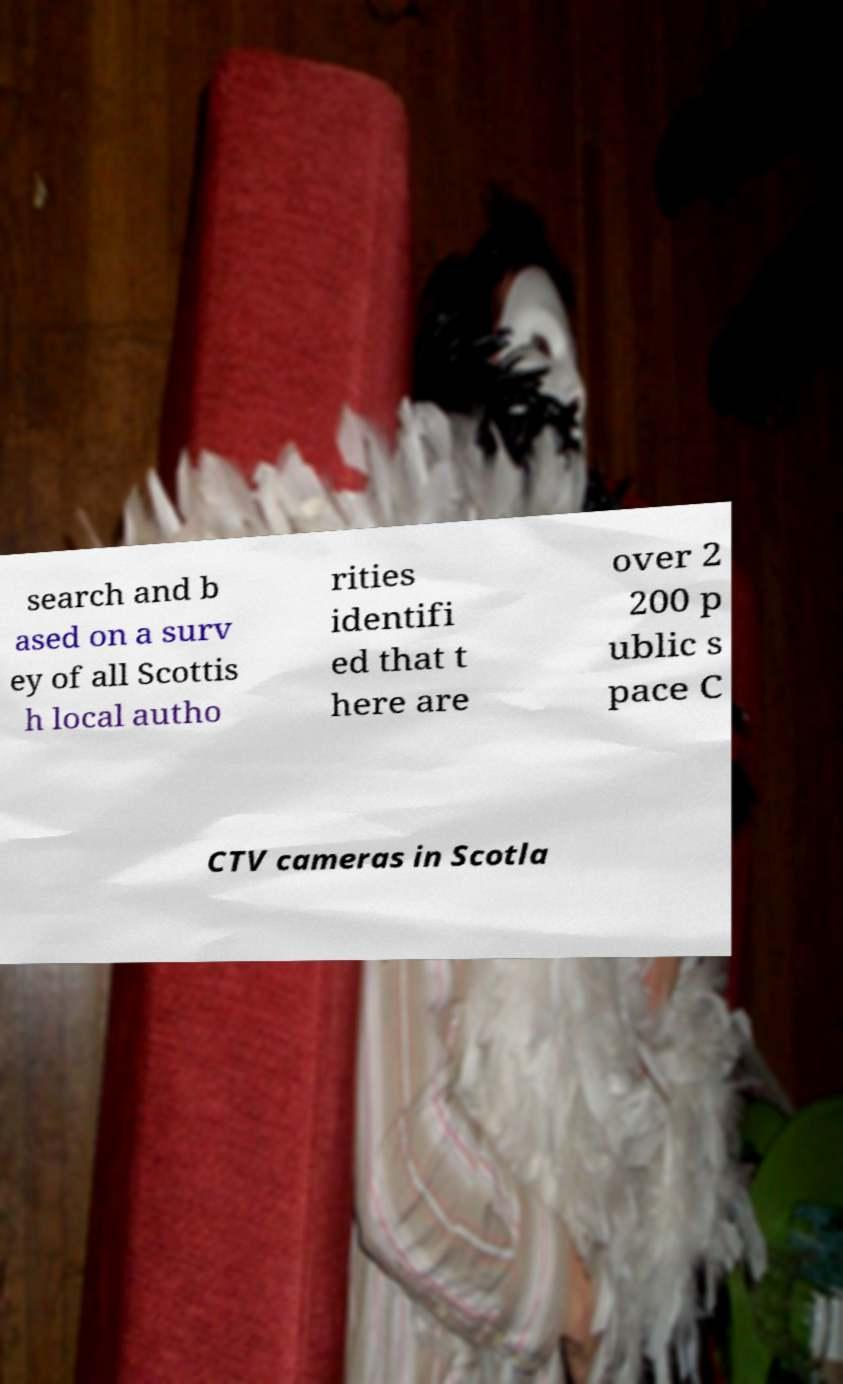Can you accurately transcribe the text from the provided image for me? search and b ased on a surv ey of all Scottis h local autho rities identifi ed that t here are over 2 200 p ublic s pace C CTV cameras in Scotla 